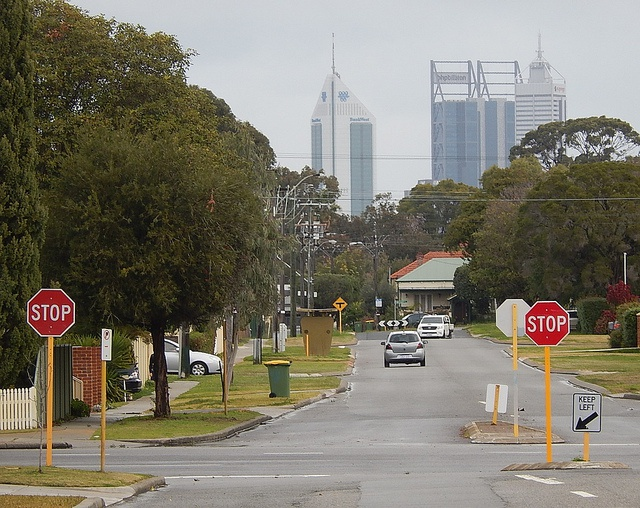Describe the objects in this image and their specific colors. I can see stop sign in black, brown, maroon, and lightgray tones, stop sign in black, brown, lightgray, and lightpink tones, car in black, gray, darkgray, and lightgray tones, car in black, lightgray, darkgray, and gray tones, and stop sign in black, darkgray, and lightgray tones in this image. 